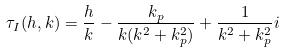Convert formula to latex. <formula><loc_0><loc_0><loc_500><loc_500>\tau _ { I } ( h , k ) = \frac { h } { k } - \frac { k _ { p } } { k ( k ^ { 2 } + k _ { p } ^ { 2 } ) } + \frac { 1 } { k ^ { 2 } + k _ { p } ^ { 2 } } i</formula> 